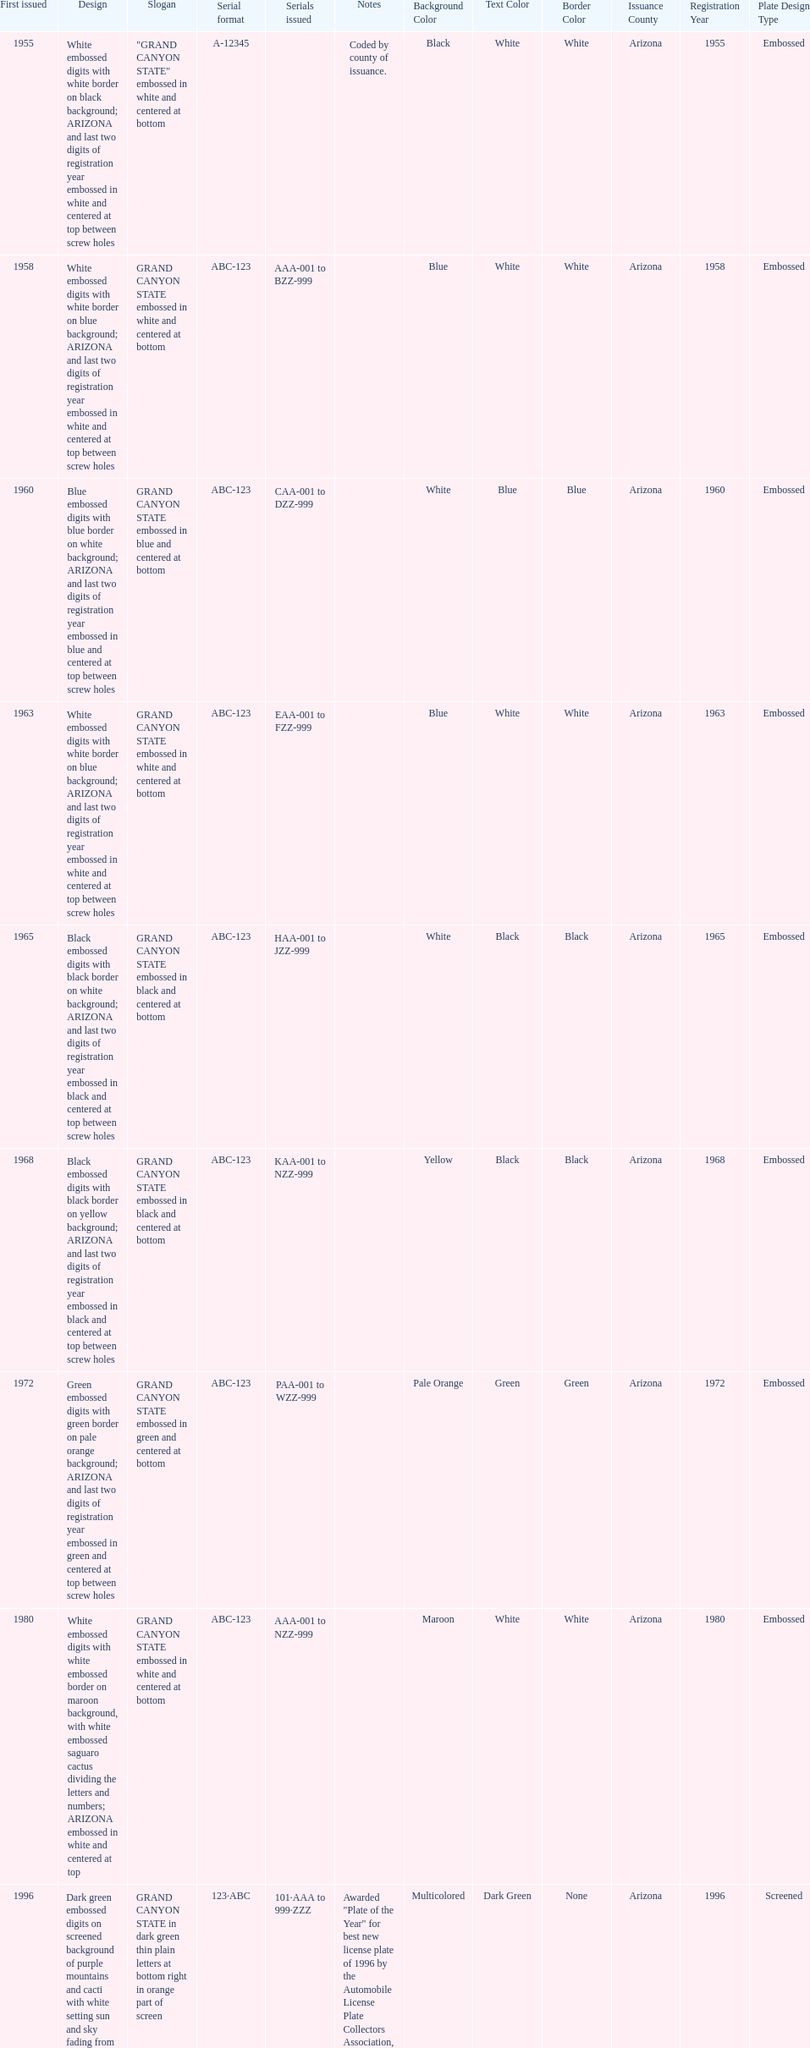In which year was the license plate with the most alphanumeric digits released? 2008. 